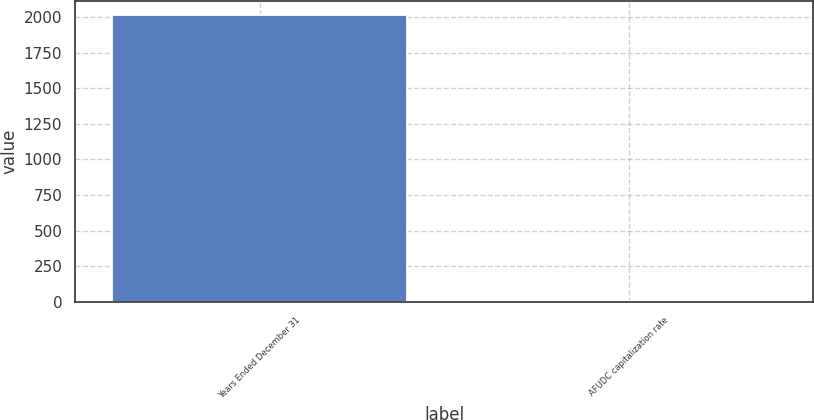Convert chart. <chart><loc_0><loc_0><loc_500><loc_500><bar_chart><fcel>Years Ended December 31<fcel>AFUDC capitalization rate<nl><fcel>2012<fcel>7.3<nl></chart> 